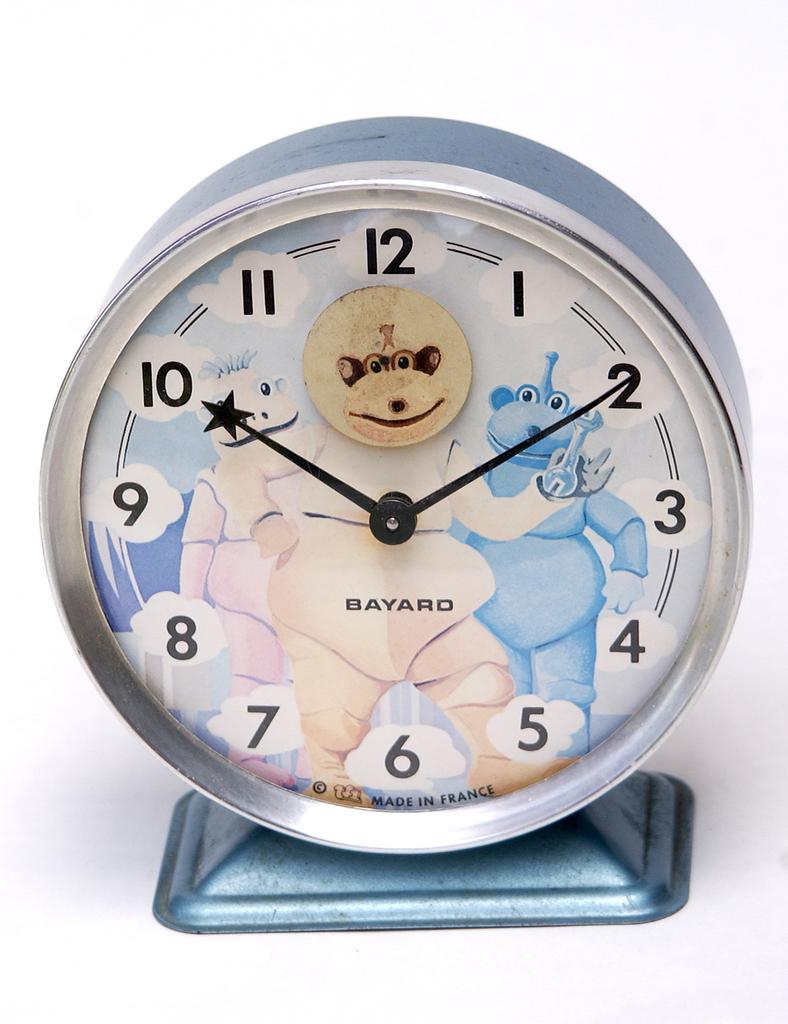<image>
Share a concise interpretation of the image provided. The clock is from Bayard and has a blue monster on it. 